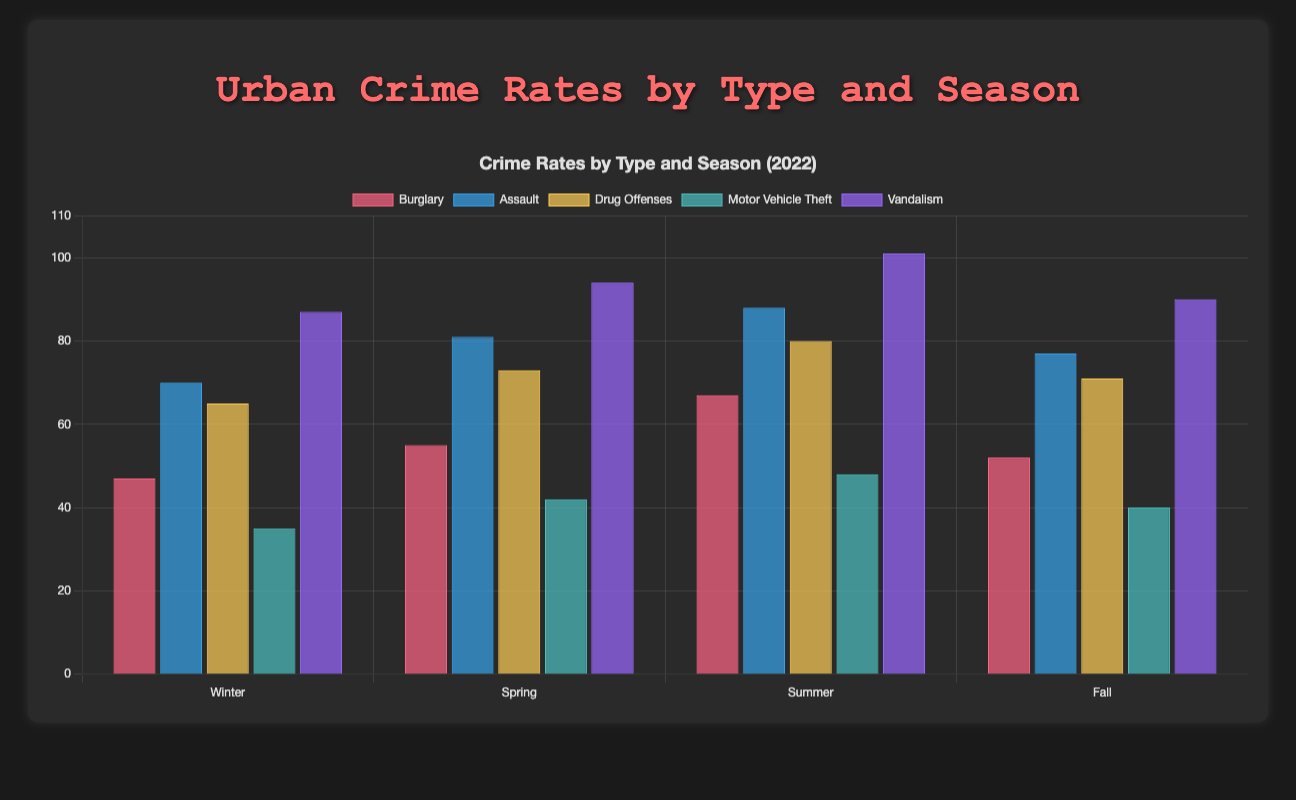Which crime type had the highest number of incidents in Summer 2022? Observing the bar heights, the highest bar in Summer 2022 corresponds to Vandalism.
Answer: Vandalism Which season experienced the highest number of Assault cases in 2022? Comparing the height of the Assault bars for each season, the Assault cases are highest in Summer 2022.
Answer: Summer What is the total number of Burglary cases in Winter and Spring of 2022? Adding the number of Burglary cases for Winter (47) and Spring (55) in 2022: 47 + 55 = 102.
Answer: 102 How does the number of Motor Vehicle Thefts in Fall compare to Summer in 2022? Comparing the heights of Motor Vehicle Theft bars, Fall has 40 cases and Summer has 48 cases. So Fall has fewer cases than Summer.
Answer: Fall has fewer Which season had the lowest number of Drug Offenses in 2022? Observing the height of the Drug Offenses bars, the shortest bar is in Winter 2022, with 65 cases.
Answer: Winter Combine Vandalism incidents from Spring and Summer 2022. Which season has more Drug Offenses compared to this sum? Vandalism in Spring (94) + Vandalism in Summer (101) = 195. No single season has more than 195 Drug Offenses in 2022.
Answer: None Which crime type showed the least fluctuation across seasons in 2022? Observing the relative heights of bars across seasons, Motor Vehicle Theft has the smallest range of values, showing the least fluctuation.
Answer: Motor Vehicle Theft What is the total number of incidents for all crime types in Summer 2022? Summing the incidents: Burglary (67) + Assault (88) + Drug Offenses (80) + Motor Vehicle Theft (48) + Vandalism (101) = 384.
Answer: 384 Which two crime types had the highest number of incidents combined in Fall 2022? Adding pairs: Burglary (52) + Assault (77) = 129, Burglary + Drug Offenses (71) = 123, Vandalism (90) + Assault = 167. The highest combination is Vandalism + Assault = 167.
Answer: Vandalism and Assault 